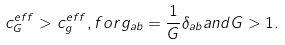<formula> <loc_0><loc_0><loc_500><loc_500>c _ { G } ^ { e f f } > c _ { g } ^ { e f f } , f o r g _ { a b } = \frac { 1 } { G } \delta _ { a b } a n d G > 1 .</formula> 